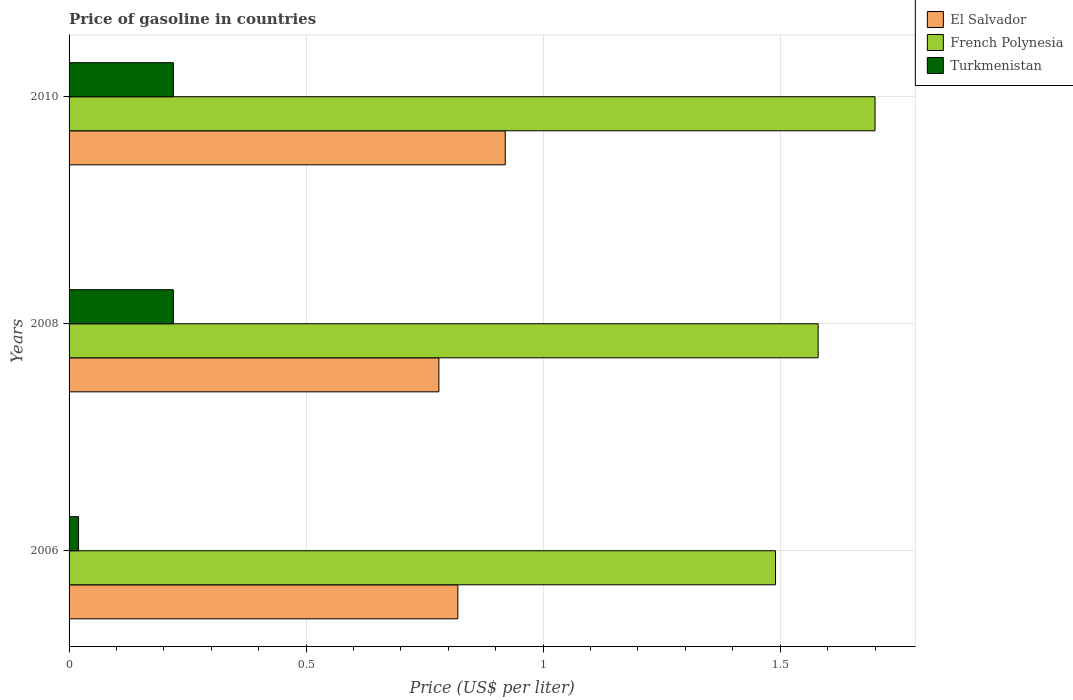How many different coloured bars are there?
Your response must be concise. 3. Are the number of bars per tick equal to the number of legend labels?
Ensure brevity in your answer.  Yes. How many bars are there on the 3rd tick from the bottom?
Offer a terse response. 3. What is the price of gasoline in El Salvador in 2006?
Offer a very short reply. 0.82. Across all years, what is the maximum price of gasoline in Turkmenistan?
Your response must be concise. 0.22. Across all years, what is the minimum price of gasoline in Turkmenistan?
Your response must be concise. 0.02. In which year was the price of gasoline in Turkmenistan maximum?
Provide a succinct answer. 2008. What is the total price of gasoline in Turkmenistan in the graph?
Offer a very short reply. 0.46. What is the difference between the price of gasoline in French Polynesia in 2006 and that in 2010?
Keep it short and to the point. -0.21. What is the difference between the price of gasoline in El Salvador in 2010 and the price of gasoline in Turkmenistan in 2008?
Ensure brevity in your answer.  0.7. What is the average price of gasoline in El Salvador per year?
Give a very brief answer. 0.84. In the year 2010, what is the difference between the price of gasoline in Turkmenistan and price of gasoline in French Polynesia?
Ensure brevity in your answer.  -1.48. What is the ratio of the price of gasoline in French Polynesia in 2006 to that in 2008?
Make the answer very short. 0.94. What is the difference between the highest and the second highest price of gasoline in El Salvador?
Your answer should be compact. 0.1. What is the difference between the highest and the lowest price of gasoline in El Salvador?
Provide a short and direct response. 0.14. In how many years, is the price of gasoline in French Polynesia greater than the average price of gasoline in French Polynesia taken over all years?
Offer a very short reply. 1. Is the sum of the price of gasoline in El Salvador in 2006 and 2010 greater than the maximum price of gasoline in French Polynesia across all years?
Give a very brief answer. Yes. What does the 1st bar from the top in 2008 represents?
Provide a succinct answer. Turkmenistan. What does the 1st bar from the bottom in 2006 represents?
Provide a succinct answer. El Salvador. Is it the case that in every year, the sum of the price of gasoline in Turkmenistan and price of gasoline in El Salvador is greater than the price of gasoline in French Polynesia?
Your answer should be very brief. No. How many bars are there?
Your response must be concise. 9. Are all the bars in the graph horizontal?
Offer a terse response. Yes. What is the difference between two consecutive major ticks on the X-axis?
Ensure brevity in your answer.  0.5. Are the values on the major ticks of X-axis written in scientific E-notation?
Provide a short and direct response. No. Does the graph contain any zero values?
Give a very brief answer. No. Does the graph contain grids?
Your answer should be compact. Yes. How many legend labels are there?
Ensure brevity in your answer.  3. What is the title of the graph?
Provide a short and direct response. Price of gasoline in countries. Does "Monaco" appear as one of the legend labels in the graph?
Offer a terse response. No. What is the label or title of the X-axis?
Give a very brief answer. Price (US$ per liter). What is the label or title of the Y-axis?
Your answer should be compact. Years. What is the Price (US$ per liter) in El Salvador in 2006?
Offer a very short reply. 0.82. What is the Price (US$ per liter) in French Polynesia in 2006?
Keep it short and to the point. 1.49. What is the Price (US$ per liter) of Turkmenistan in 2006?
Provide a succinct answer. 0.02. What is the Price (US$ per liter) in El Salvador in 2008?
Your answer should be very brief. 0.78. What is the Price (US$ per liter) of French Polynesia in 2008?
Your answer should be compact. 1.58. What is the Price (US$ per liter) of Turkmenistan in 2008?
Offer a very short reply. 0.22. What is the Price (US$ per liter) of El Salvador in 2010?
Provide a short and direct response. 0.92. What is the Price (US$ per liter) of Turkmenistan in 2010?
Your answer should be very brief. 0.22. Across all years, what is the maximum Price (US$ per liter) in El Salvador?
Your answer should be very brief. 0.92. Across all years, what is the maximum Price (US$ per liter) of French Polynesia?
Provide a succinct answer. 1.7. Across all years, what is the maximum Price (US$ per liter) in Turkmenistan?
Give a very brief answer. 0.22. Across all years, what is the minimum Price (US$ per liter) in El Salvador?
Keep it short and to the point. 0.78. Across all years, what is the minimum Price (US$ per liter) in French Polynesia?
Provide a short and direct response. 1.49. What is the total Price (US$ per liter) of El Salvador in the graph?
Ensure brevity in your answer.  2.52. What is the total Price (US$ per liter) of French Polynesia in the graph?
Offer a very short reply. 4.77. What is the total Price (US$ per liter) of Turkmenistan in the graph?
Keep it short and to the point. 0.46. What is the difference between the Price (US$ per liter) in El Salvador in 2006 and that in 2008?
Offer a terse response. 0.04. What is the difference between the Price (US$ per liter) of French Polynesia in 2006 and that in 2008?
Offer a terse response. -0.09. What is the difference between the Price (US$ per liter) in El Salvador in 2006 and that in 2010?
Keep it short and to the point. -0.1. What is the difference between the Price (US$ per liter) in French Polynesia in 2006 and that in 2010?
Ensure brevity in your answer.  -0.21. What is the difference between the Price (US$ per liter) of El Salvador in 2008 and that in 2010?
Offer a terse response. -0.14. What is the difference between the Price (US$ per liter) of French Polynesia in 2008 and that in 2010?
Keep it short and to the point. -0.12. What is the difference between the Price (US$ per liter) of Turkmenistan in 2008 and that in 2010?
Provide a short and direct response. 0. What is the difference between the Price (US$ per liter) of El Salvador in 2006 and the Price (US$ per liter) of French Polynesia in 2008?
Offer a terse response. -0.76. What is the difference between the Price (US$ per liter) in El Salvador in 2006 and the Price (US$ per liter) in Turkmenistan in 2008?
Your answer should be compact. 0.6. What is the difference between the Price (US$ per liter) of French Polynesia in 2006 and the Price (US$ per liter) of Turkmenistan in 2008?
Ensure brevity in your answer.  1.27. What is the difference between the Price (US$ per liter) of El Salvador in 2006 and the Price (US$ per liter) of French Polynesia in 2010?
Your answer should be very brief. -0.88. What is the difference between the Price (US$ per liter) in French Polynesia in 2006 and the Price (US$ per liter) in Turkmenistan in 2010?
Ensure brevity in your answer.  1.27. What is the difference between the Price (US$ per liter) of El Salvador in 2008 and the Price (US$ per liter) of French Polynesia in 2010?
Keep it short and to the point. -0.92. What is the difference between the Price (US$ per liter) in El Salvador in 2008 and the Price (US$ per liter) in Turkmenistan in 2010?
Give a very brief answer. 0.56. What is the difference between the Price (US$ per liter) of French Polynesia in 2008 and the Price (US$ per liter) of Turkmenistan in 2010?
Provide a short and direct response. 1.36. What is the average Price (US$ per liter) in El Salvador per year?
Provide a succinct answer. 0.84. What is the average Price (US$ per liter) of French Polynesia per year?
Your response must be concise. 1.59. What is the average Price (US$ per liter) in Turkmenistan per year?
Offer a very short reply. 0.15. In the year 2006, what is the difference between the Price (US$ per liter) of El Salvador and Price (US$ per liter) of French Polynesia?
Your answer should be very brief. -0.67. In the year 2006, what is the difference between the Price (US$ per liter) of El Salvador and Price (US$ per liter) of Turkmenistan?
Your answer should be very brief. 0.8. In the year 2006, what is the difference between the Price (US$ per liter) of French Polynesia and Price (US$ per liter) of Turkmenistan?
Keep it short and to the point. 1.47. In the year 2008, what is the difference between the Price (US$ per liter) in El Salvador and Price (US$ per liter) in Turkmenistan?
Provide a short and direct response. 0.56. In the year 2008, what is the difference between the Price (US$ per liter) of French Polynesia and Price (US$ per liter) of Turkmenistan?
Provide a short and direct response. 1.36. In the year 2010, what is the difference between the Price (US$ per liter) of El Salvador and Price (US$ per liter) of French Polynesia?
Your response must be concise. -0.78. In the year 2010, what is the difference between the Price (US$ per liter) of French Polynesia and Price (US$ per liter) of Turkmenistan?
Offer a terse response. 1.48. What is the ratio of the Price (US$ per liter) in El Salvador in 2006 to that in 2008?
Ensure brevity in your answer.  1.05. What is the ratio of the Price (US$ per liter) in French Polynesia in 2006 to that in 2008?
Ensure brevity in your answer.  0.94. What is the ratio of the Price (US$ per liter) of Turkmenistan in 2006 to that in 2008?
Make the answer very short. 0.09. What is the ratio of the Price (US$ per liter) in El Salvador in 2006 to that in 2010?
Provide a short and direct response. 0.89. What is the ratio of the Price (US$ per liter) of French Polynesia in 2006 to that in 2010?
Your response must be concise. 0.88. What is the ratio of the Price (US$ per liter) in Turkmenistan in 2006 to that in 2010?
Make the answer very short. 0.09. What is the ratio of the Price (US$ per liter) of El Salvador in 2008 to that in 2010?
Your response must be concise. 0.85. What is the ratio of the Price (US$ per liter) in French Polynesia in 2008 to that in 2010?
Your answer should be very brief. 0.93. What is the ratio of the Price (US$ per liter) in Turkmenistan in 2008 to that in 2010?
Ensure brevity in your answer.  1. What is the difference between the highest and the second highest Price (US$ per liter) in French Polynesia?
Provide a succinct answer. 0.12. What is the difference between the highest and the lowest Price (US$ per liter) in El Salvador?
Offer a terse response. 0.14. What is the difference between the highest and the lowest Price (US$ per liter) of French Polynesia?
Your response must be concise. 0.21. 